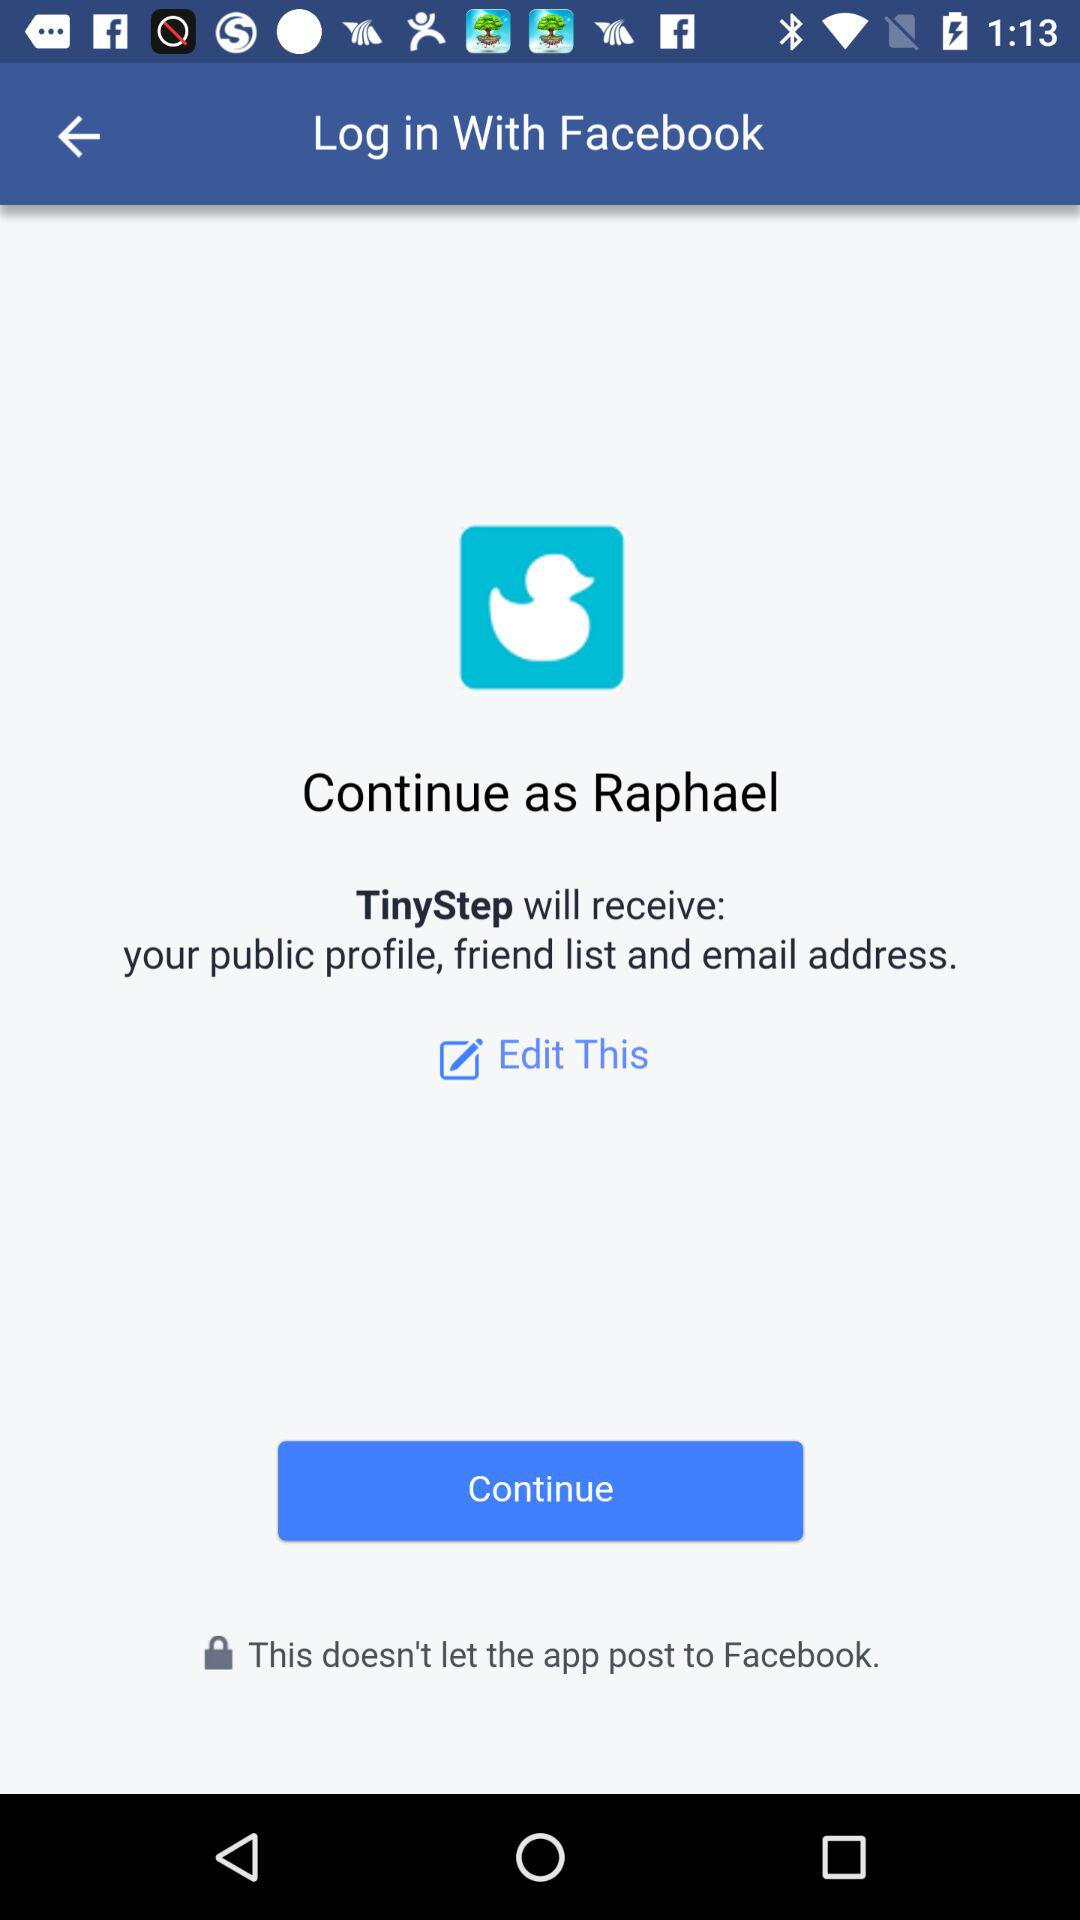What app will receive your email address? The email address will be received by "TinyStep". 